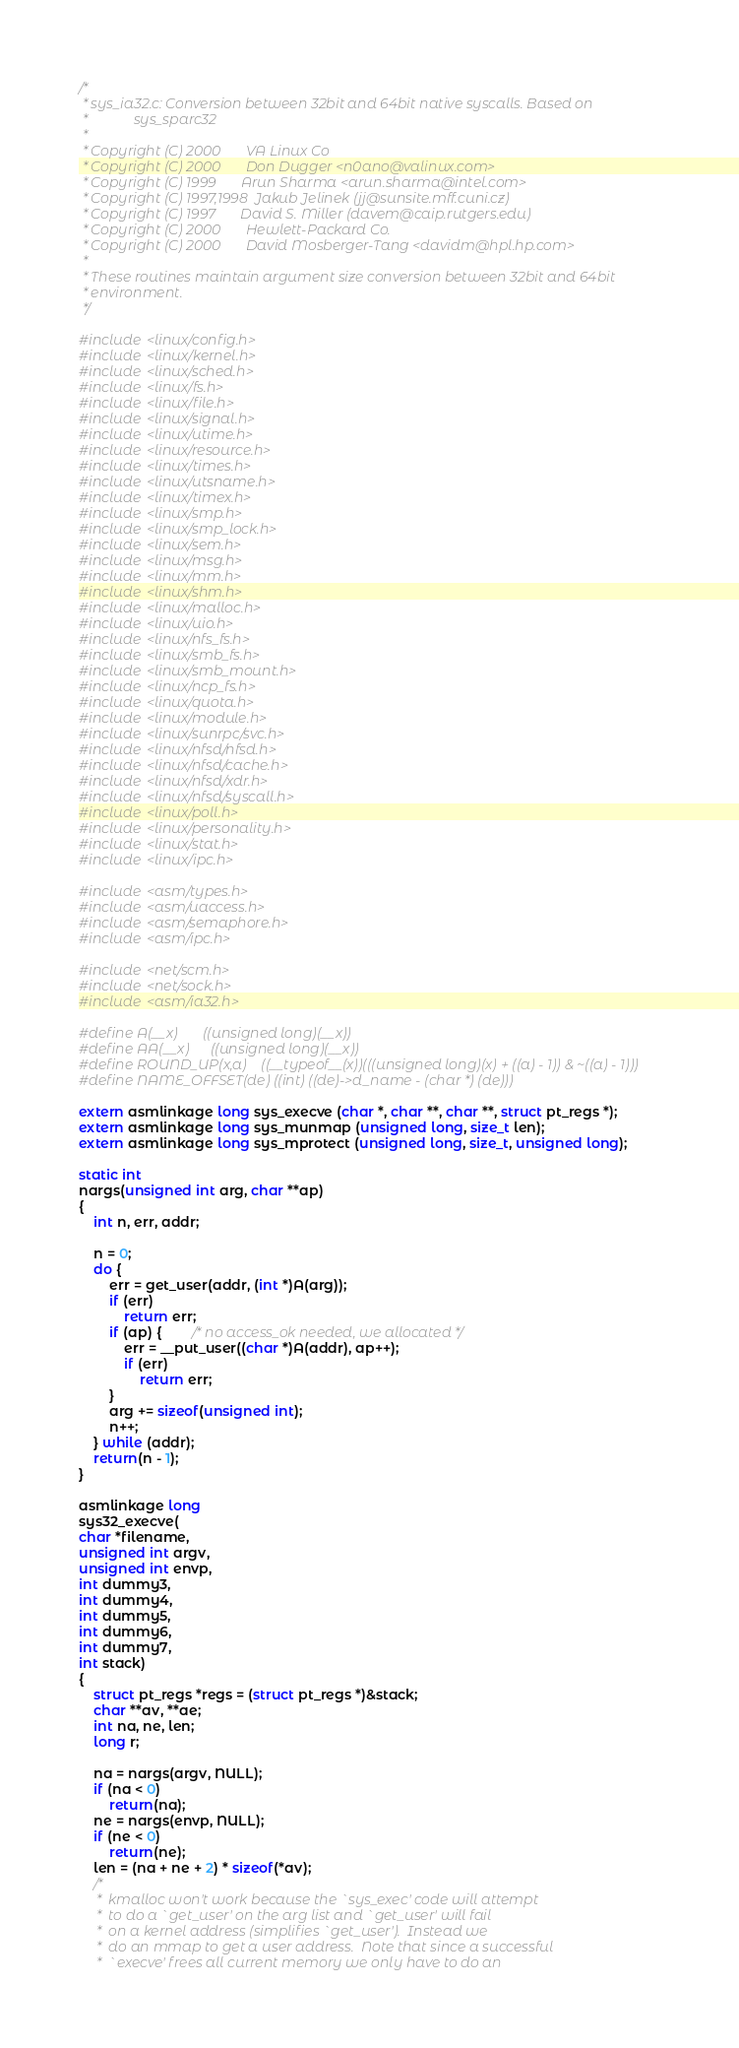Convert code to text. <code><loc_0><loc_0><loc_500><loc_500><_C_>/*
 * sys_ia32.c: Conversion between 32bit and 64bit native syscalls. Based on
 *             sys_sparc32 
 *
 * Copyright (C) 2000		VA Linux Co
 * Copyright (C) 2000		Don Dugger <n0ano@valinux.com>
 * Copyright (C) 1999 		Arun Sharma <arun.sharma@intel.com>
 * Copyright (C) 1997,1998 	Jakub Jelinek (jj@sunsite.mff.cuni.cz)
 * Copyright (C) 1997 		David S. Miller (davem@caip.rutgers.edu)
 * Copyright (C) 2000		Hewlett-Packard Co.
 * Copyright (C) 2000		David Mosberger-Tang <davidm@hpl.hp.com>
 *
 * These routines maintain argument size conversion between 32bit and 64bit
 * environment.
 */

#include <linux/config.h>
#include <linux/kernel.h>
#include <linux/sched.h>
#include <linux/fs.h> 
#include <linux/file.h> 
#include <linux/signal.h>
#include <linux/utime.h>
#include <linux/resource.h>
#include <linux/times.h>
#include <linux/utsname.h>
#include <linux/timex.h>
#include <linux/smp.h>
#include <linux/smp_lock.h>
#include <linux/sem.h>
#include <linux/msg.h>
#include <linux/mm.h>
#include <linux/shm.h>
#include <linux/malloc.h>
#include <linux/uio.h>
#include <linux/nfs_fs.h>
#include <linux/smb_fs.h>
#include <linux/smb_mount.h>
#include <linux/ncp_fs.h>
#include <linux/quota.h>
#include <linux/module.h>
#include <linux/sunrpc/svc.h>
#include <linux/nfsd/nfsd.h>
#include <linux/nfsd/cache.h>
#include <linux/nfsd/xdr.h>
#include <linux/nfsd/syscall.h>
#include <linux/poll.h>
#include <linux/personality.h>
#include <linux/stat.h>
#include <linux/ipc.h>

#include <asm/types.h>
#include <asm/uaccess.h>
#include <asm/semaphore.h>
#include <asm/ipc.h>

#include <net/scm.h>
#include <net/sock.h>
#include <asm/ia32.h>

#define A(__x)		((unsigned long)(__x))
#define AA(__x)		((unsigned long)(__x))
#define ROUND_UP(x,a)	((__typeof__(x))(((unsigned long)(x) + ((a) - 1)) & ~((a) - 1)))
#define NAME_OFFSET(de) ((int) ((de)->d_name - (char *) (de)))

extern asmlinkage long sys_execve (char *, char **, char **, struct pt_regs *);
extern asmlinkage long sys_munmap (unsigned long, size_t len);
extern asmlinkage long sys_mprotect (unsigned long, size_t, unsigned long);

static int
nargs(unsigned int arg, char **ap)
{
	int n, err, addr;

	n = 0;
	do {
		err = get_user(addr, (int *)A(arg));
		if (err)
			return err;
		if (ap) {		/* no access_ok needed, we allocated */
			err = __put_user((char *)A(addr), ap++);
			if (err)
				return err;
		}
		arg += sizeof(unsigned int);
		n++;
	} while (addr);
	return(n - 1);
}

asmlinkage long
sys32_execve(
char *filename,
unsigned int argv,
unsigned int envp,
int dummy3,
int dummy4,
int dummy5,
int dummy6,
int dummy7,
int stack)
{
	struct pt_regs *regs = (struct pt_regs *)&stack;
	char **av, **ae;
	int na, ne, len;
	long r;

	na = nargs(argv, NULL);
	if (na < 0)
		return(na);
	ne = nargs(envp, NULL);
	if (ne < 0)
		return(ne);
	len = (na + ne + 2) * sizeof(*av);
	/*
	 *  kmalloc won't work because the `sys_exec' code will attempt
	 *  to do a `get_user' on the arg list and `get_user' will fail
	 *  on a kernel address (simplifies `get_user').  Instead we
	 *  do an mmap to get a user address.  Note that since a successful
	 *  `execve' frees all current memory we only have to do an</code> 